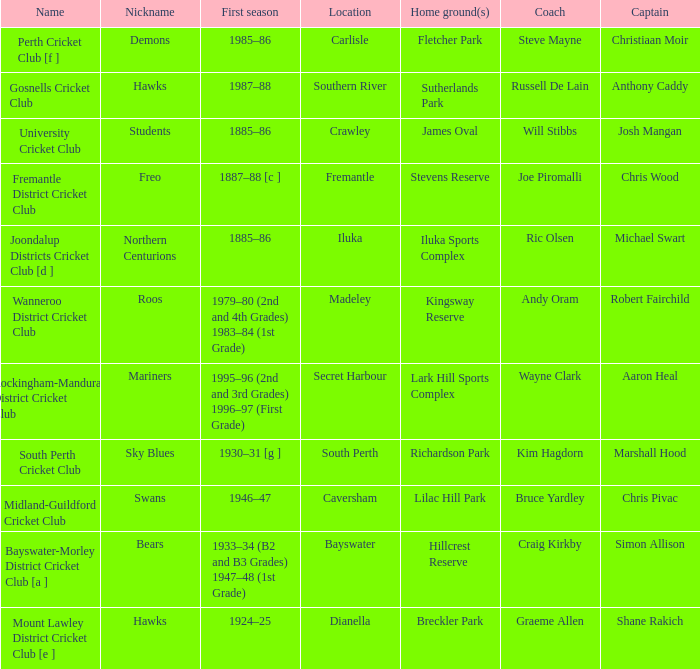For location Caversham, what is the name of the captain? Chris Pivac. 